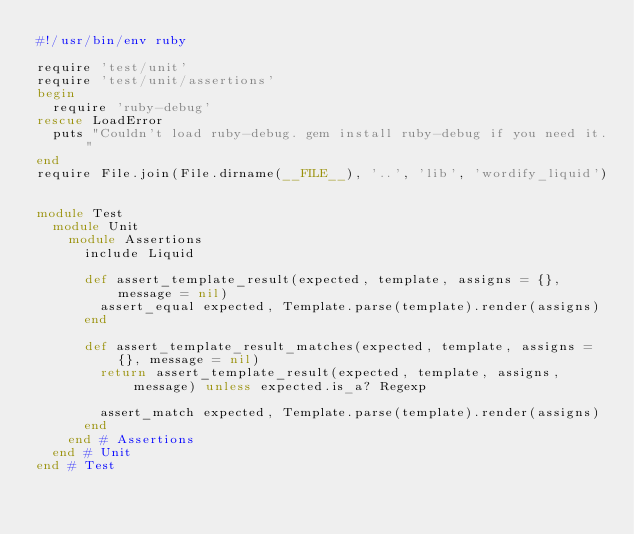<code> <loc_0><loc_0><loc_500><loc_500><_Ruby_>#!/usr/bin/env ruby

require 'test/unit'
require 'test/unit/assertions'
begin
  require 'ruby-debug'
rescue LoadError
  puts "Couldn't load ruby-debug. gem install ruby-debug if you need it."
end
require File.join(File.dirname(__FILE__), '..', 'lib', 'wordify_liquid')


module Test
  module Unit
    module Assertions
      include Liquid

      def assert_template_result(expected, template, assigns = {}, message = nil)
        assert_equal expected, Template.parse(template).render(assigns)
      end

      def assert_template_result_matches(expected, template, assigns = {}, message = nil)
        return assert_template_result(expected, template, assigns, message) unless expected.is_a? Regexp

        assert_match expected, Template.parse(template).render(assigns)
      end
    end # Assertions
  end # Unit
end # Test
</code> 